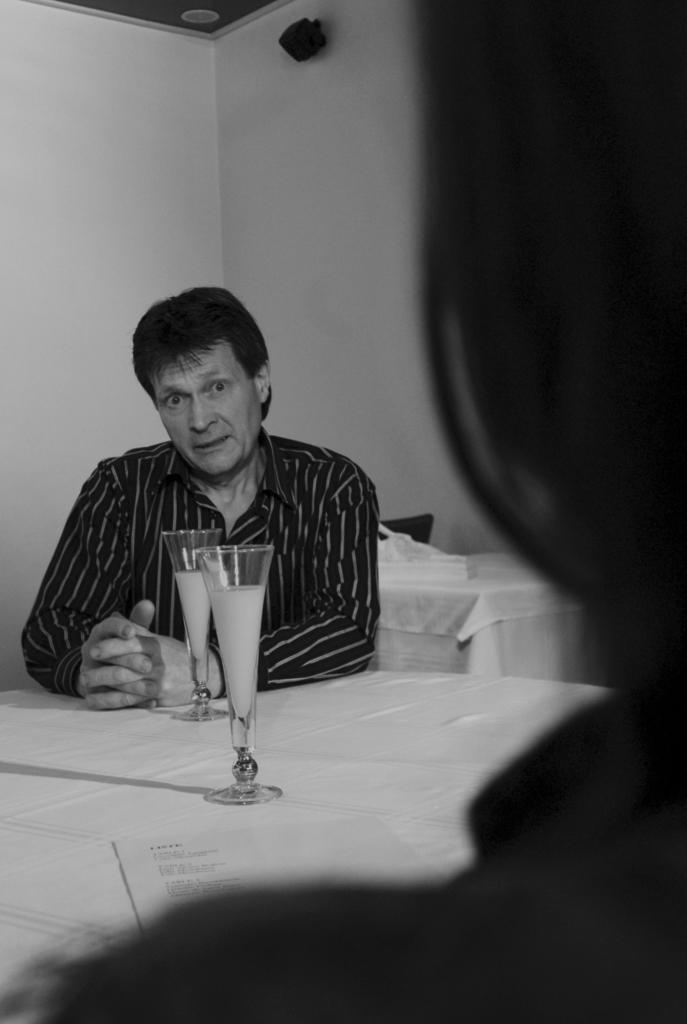What are the people in the image doing? The people in the image are seated on chairs. What is located in the center of the image? There is a table in the center of the image. What objects can be seen on the table? There are glasses and a paper on the table. What type of wound can be seen on the pig in the image? There is no pig or wound present in the image. Is there an umbrella visible in the image? No, there is no umbrella visible in the image. 